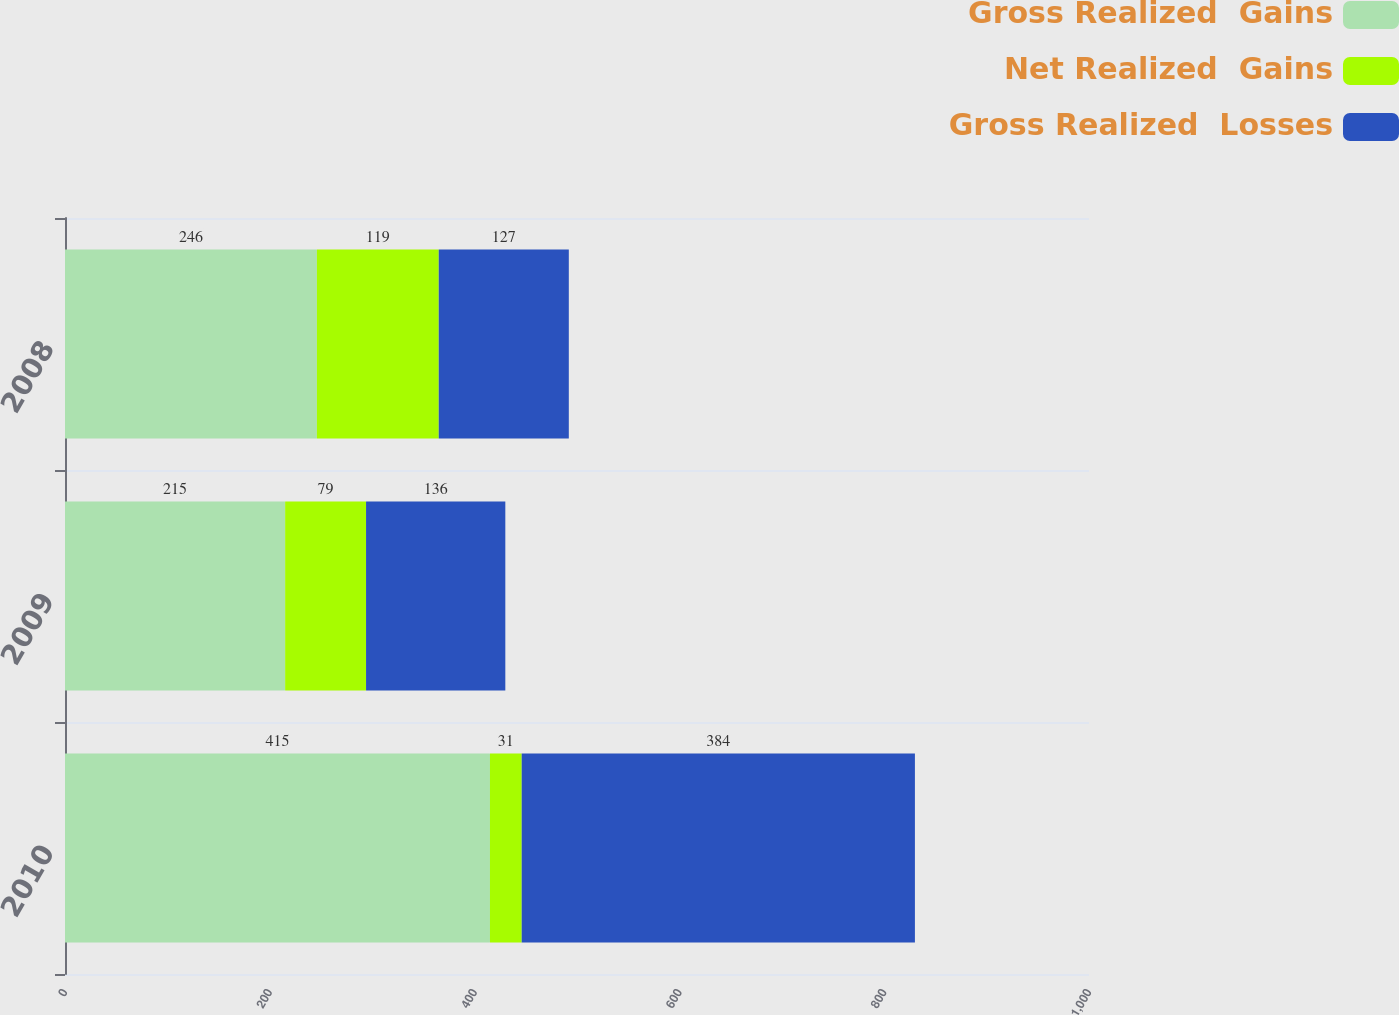Convert chart. <chart><loc_0><loc_0><loc_500><loc_500><stacked_bar_chart><ecel><fcel>2010<fcel>2009<fcel>2008<nl><fcel>Gross Realized  Gains<fcel>415<fcel>215<fcel>246<nl><fcel>Net Realized  Gains<fcel>31<fcel>79<fcel>119<nl><fcel>Gross Realized  Losses<fcel>384<fcel>136<fcel>127<nl></chart> 